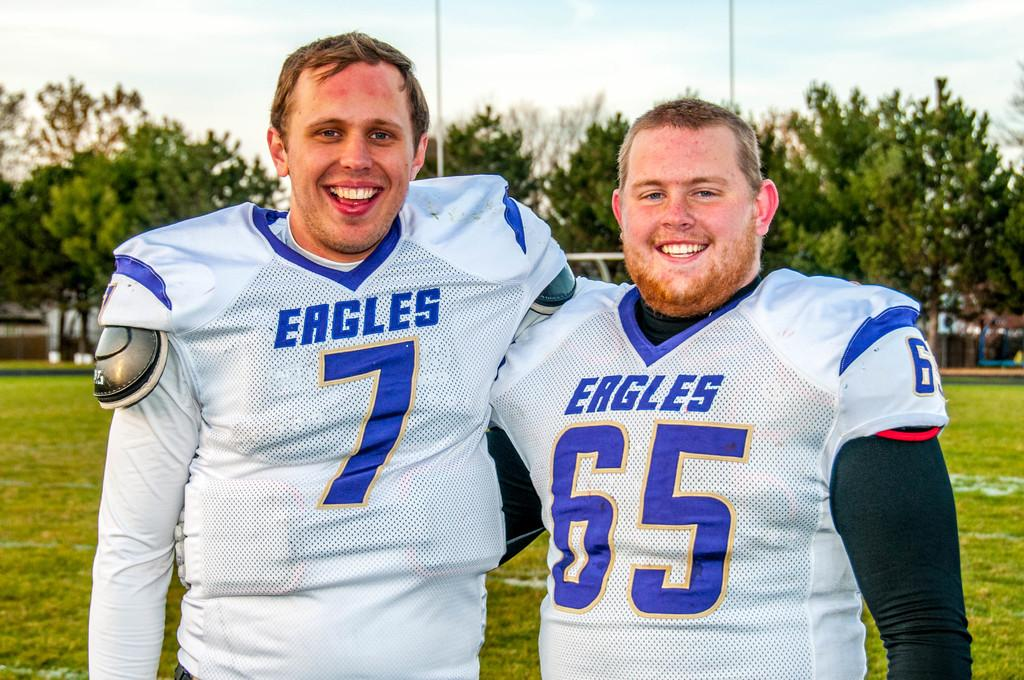Provide a one-sentence caption for the provided image. Two Eagles football players are smiling for the camera. 